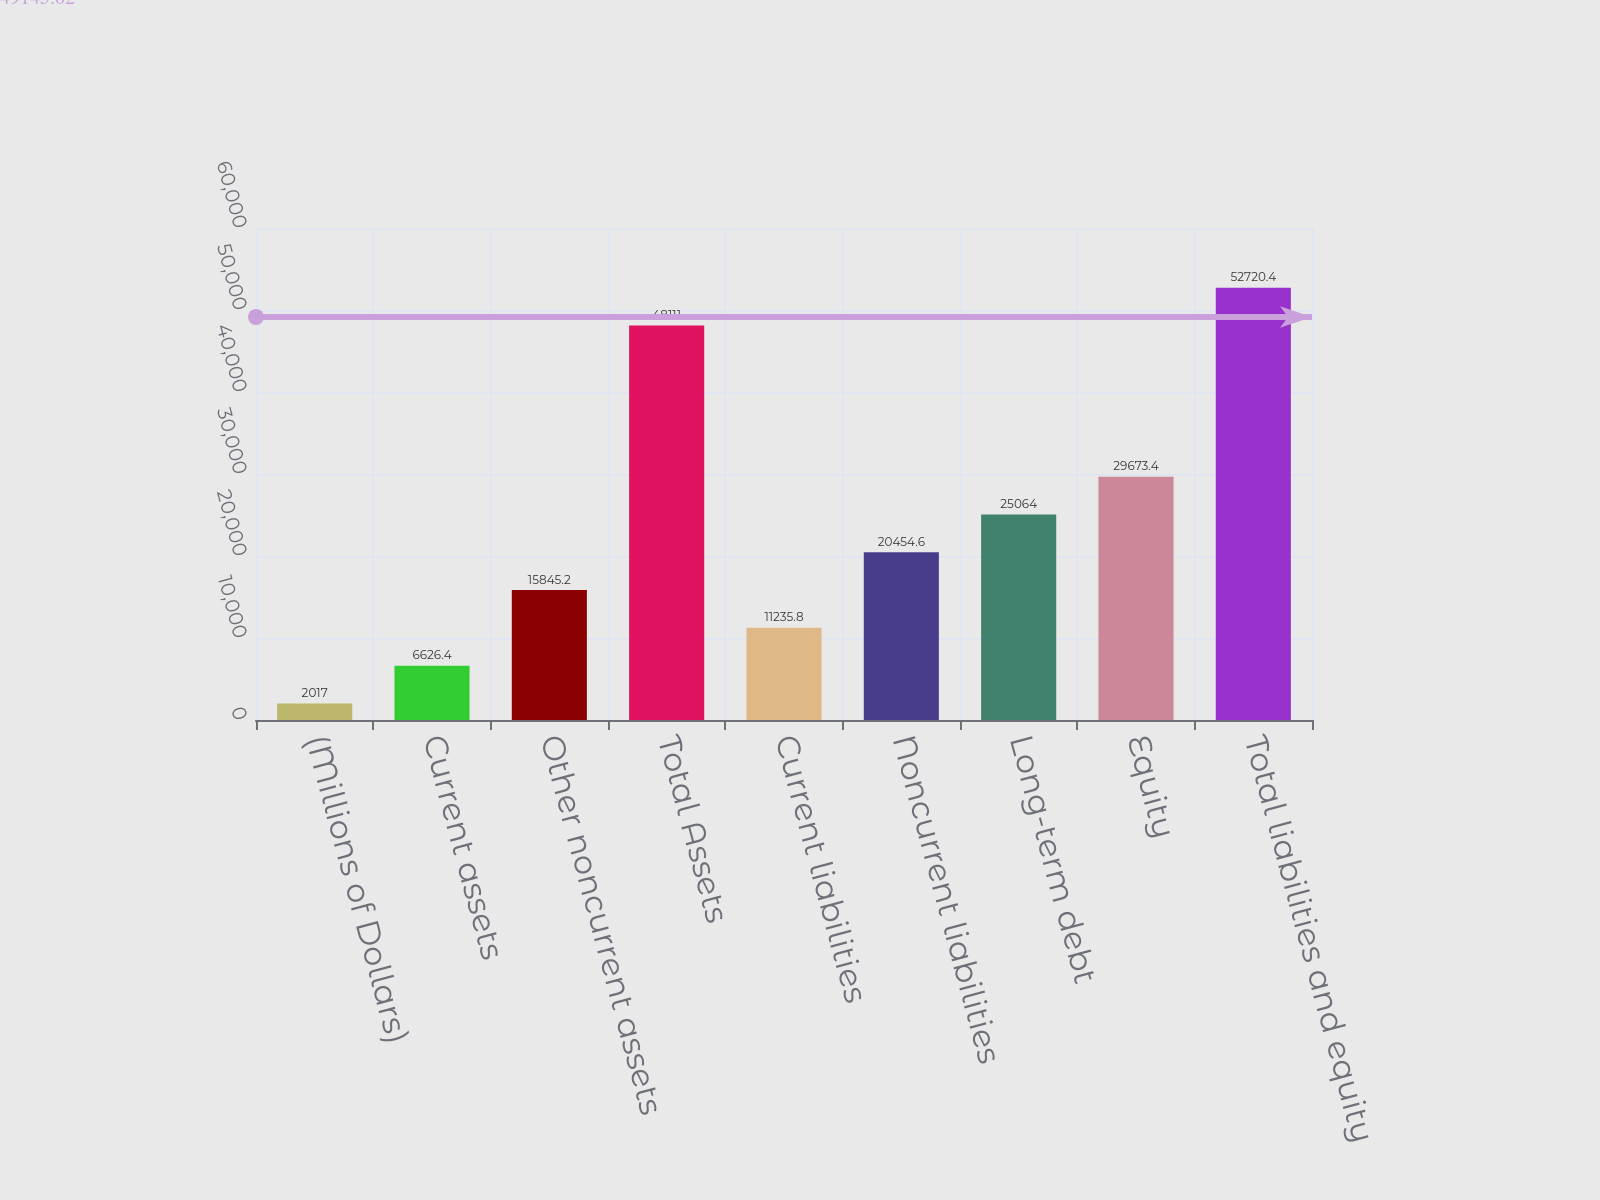<chart> <loc_0><loc_0><loc_500><loc_500><bar_chart><fcel>(Millions of Dollars)<fcel>Current assets<fcel>Other noncurrent assets<fcel>Total Assets<fcel>Current liabilities<fcel>Noncurrent liabilities<fcel>Long-term debt<fcel>Equity<fcel>Total liabilities and equity<nl><fcel>2017<fcel>6626.4<fcel>15845.2<fcel>48111<fcel>11235.8<fcel>20454.6<fcel>25064<fcel>29673.4<fcel>52720.4<nl></chart> 